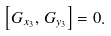Convert formula to latex. <formula><loc_0><loc_0><loc_500><loc_500>\left [ G _ { x _ { 3 } } , \, G _ { y _ { 3 } } \right ] = 0 .</formula> 